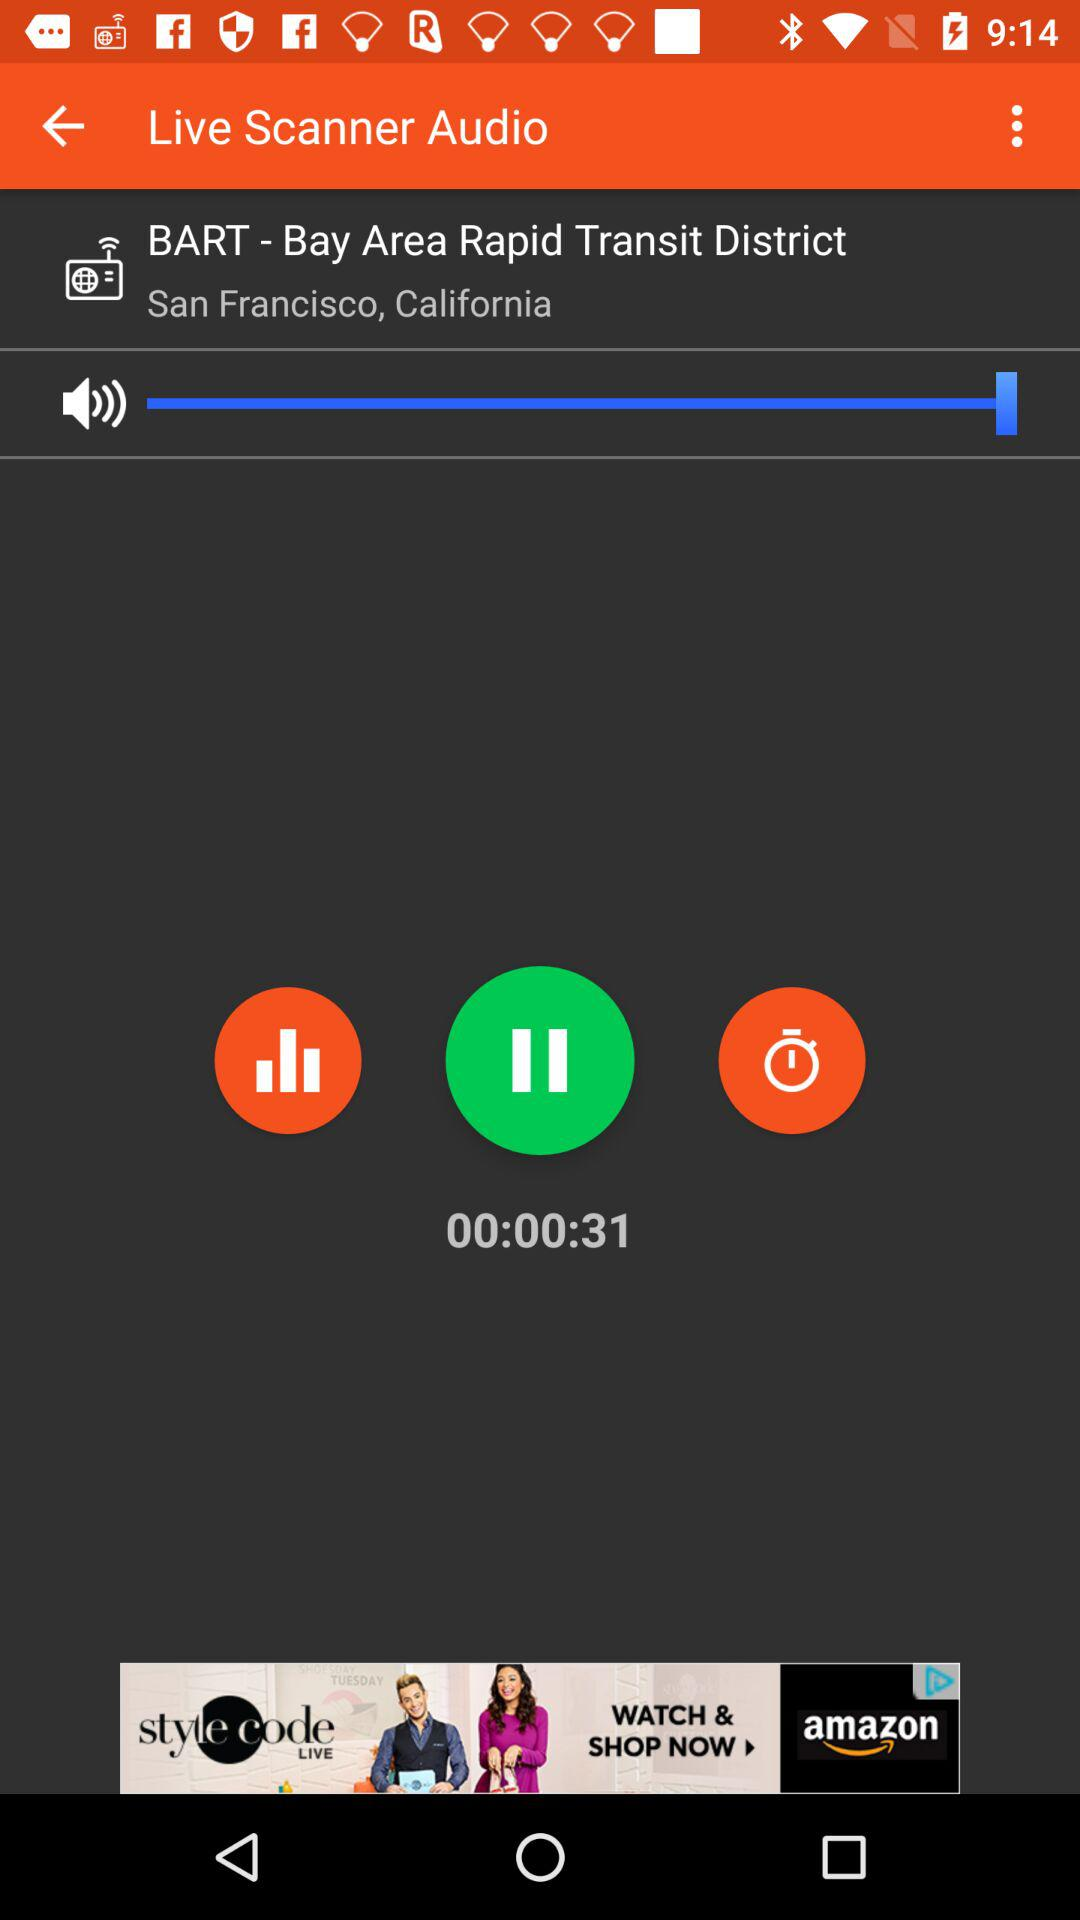What is the location? The location is San Francisco, California. 